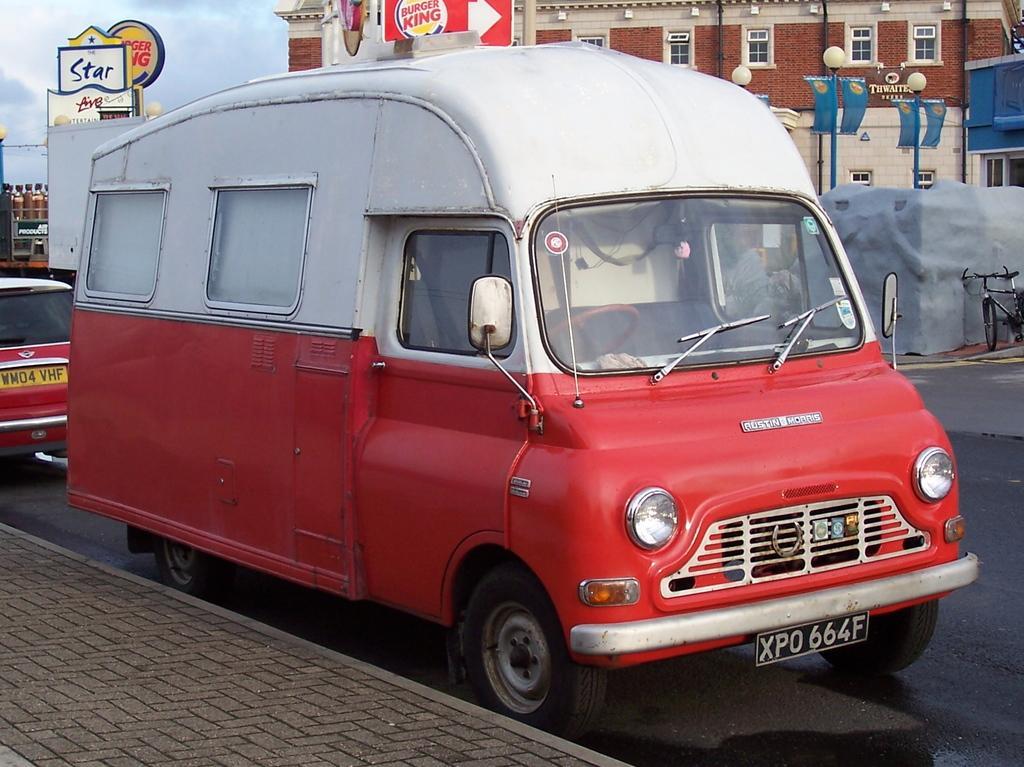In one or two sentences, can you explain what this image depicts? In this image we can see vehicles on the road, there is a pavement beside the road, in the background there are few light poles with banner, few boards with text, a building, a bicycle near the wall and the sky. 